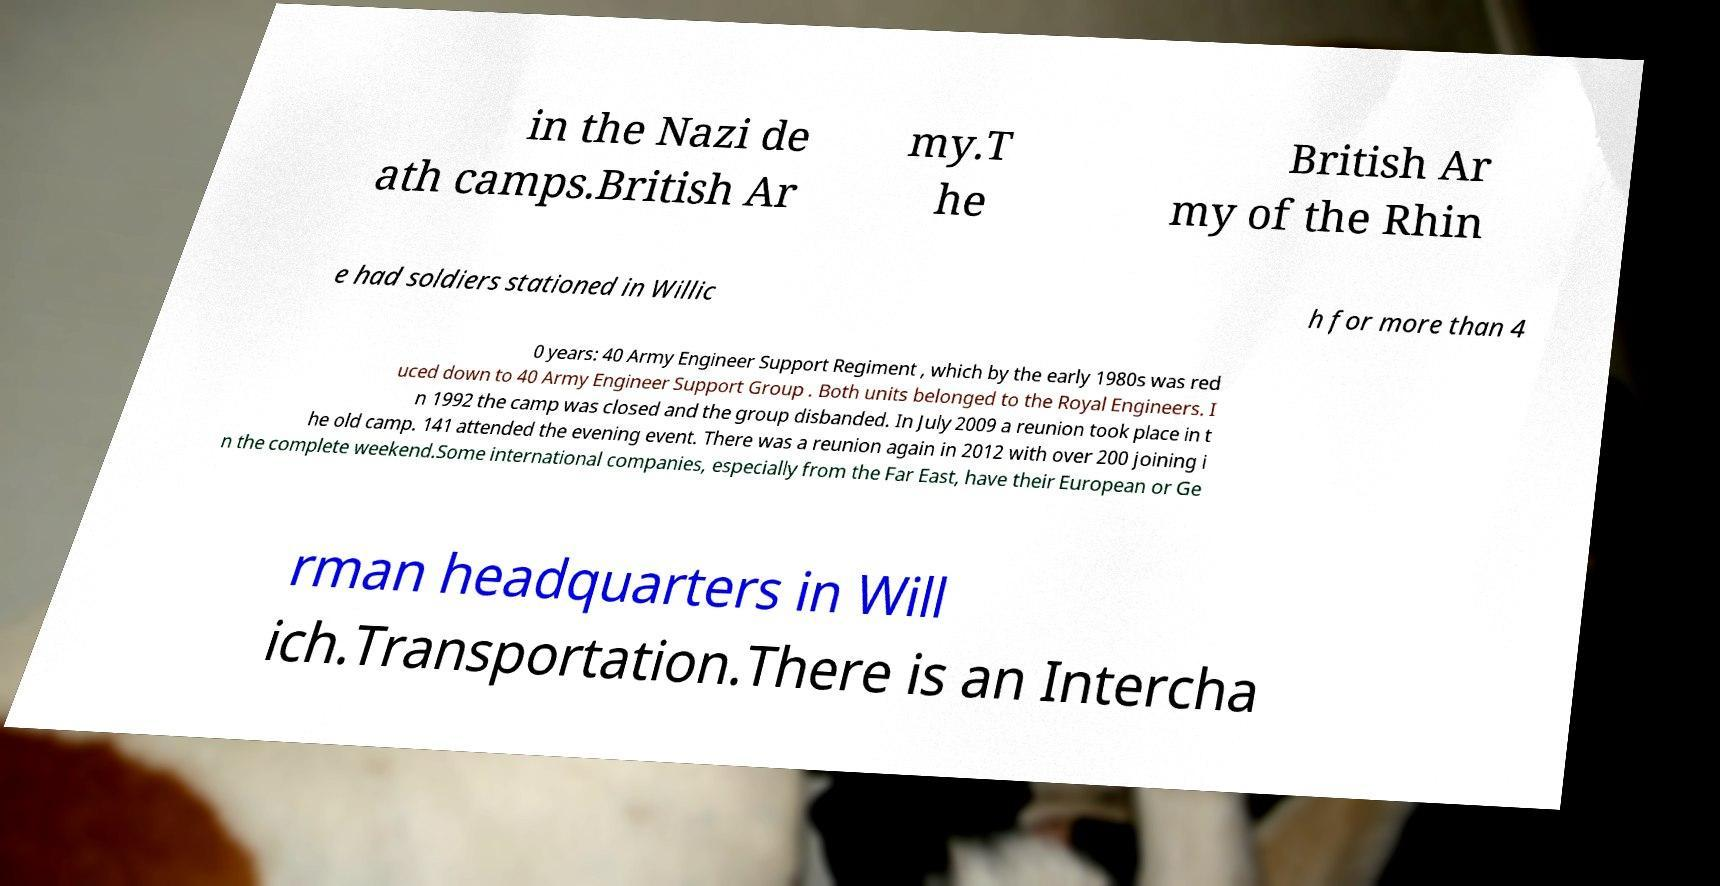For documentation purposes, I need the text within this image transcribed. Could you provide that? in the Nazi de ath camps.British Ar my.T he British Ar my of the Rhin e had soldiers stationed in Willic h for more than 4 0 years: 40 Army Engineer Support Regiment , which by the early 1980s was red uced down to 40 Army Engineer Support Group . Both units belonged to the Royal Engineers. I n 1992 the camp was closed and the group disbanded. In July 2009 a reunion took place in t he old camp. 141 attended the evening event. There was a reunion again in 2012 with over 200 joining i n the complete weekend.Some international companies, especially from the Far East, have their European or Ge rman headquarters in Will ich.Transportation.There is an Intercha 